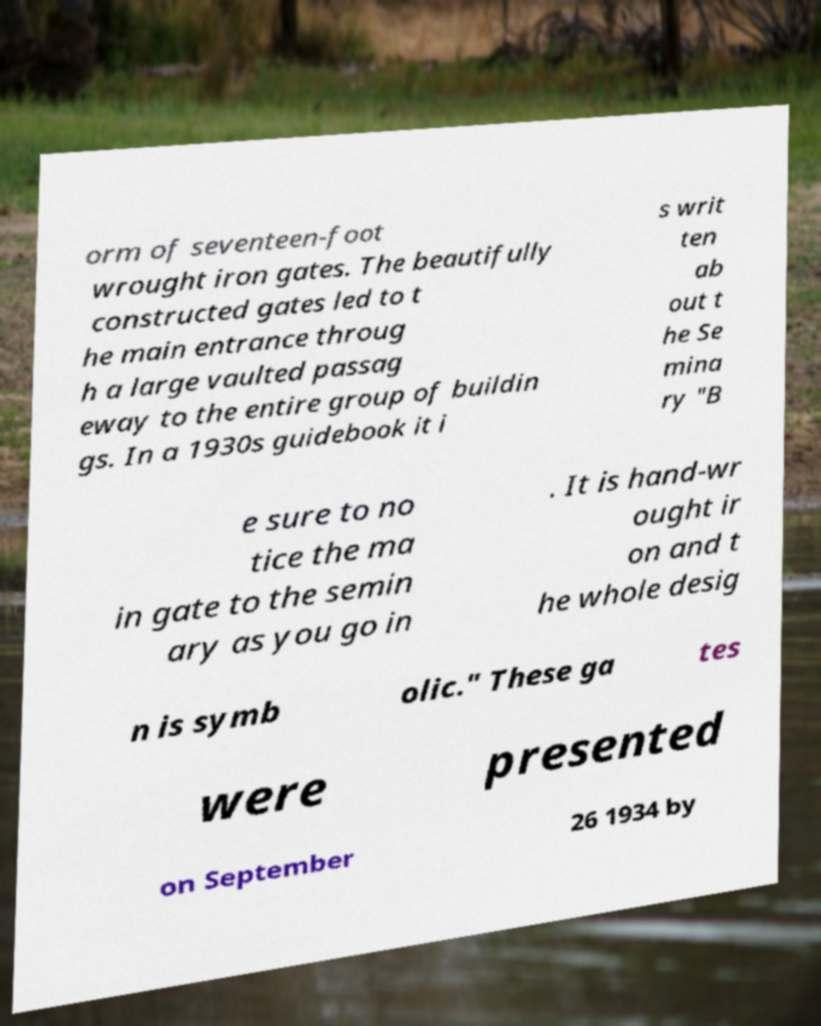Can you read and provide the text displayed in the image?This photo seems to have some interesting text. Can you extract and type it out for me? orm of seventeen-foot wrought iron gates. The beautifully constructed gates led to t he main entrance throug h a large vaulted passag eway to the entire group of buildin gs. In a 1930s guidebook it i s writ ten ab out t he Se mina ry "B e sure to no tice the ma in gate to the semin ary as you go in . It is hand-wr ought ir on and t he whole desig n is symb olic." These ga tes were presented on September 26 1934 by 